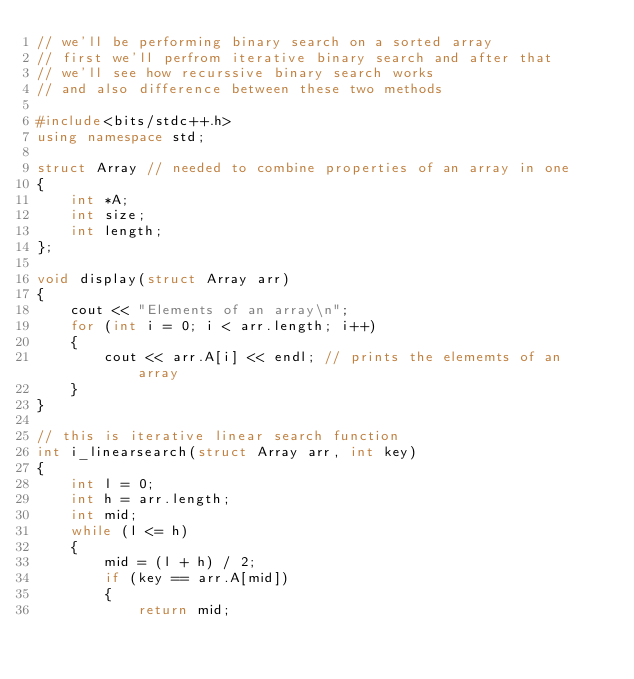Convert code to text. <code><loc_0><loc_0><loc_500><loc_500><_C++_>// we'll be performing binary search on a sorted array
// first we'll perfrom iterative binary search and after that
// we'll see how recurssive binary search works
// and also difference between these two methods

#include<bits/stdc++.h>
using namespace std;

struct Array // needed to combine properties of an array in one
{
    int *A;
    int size;
    int length;
};

void display(struct Array arr)
{
    cout << "Elements of an array\n";
    for (int i = 0; i < arr.length; i++)
    {
        cout << arr.A[i] << endl; // prints the elememts of an array
    }
}

// this is iterative linear search function
int i_linearsearch(struct Array arr, int key)
{
    int l = 0;
    int h = arr.length;
    int mid;
    while (l <= h)
    {
        mid = (l + h) / 2;
        if (key == arr.A[mid])
        {
            return mid;</code> 